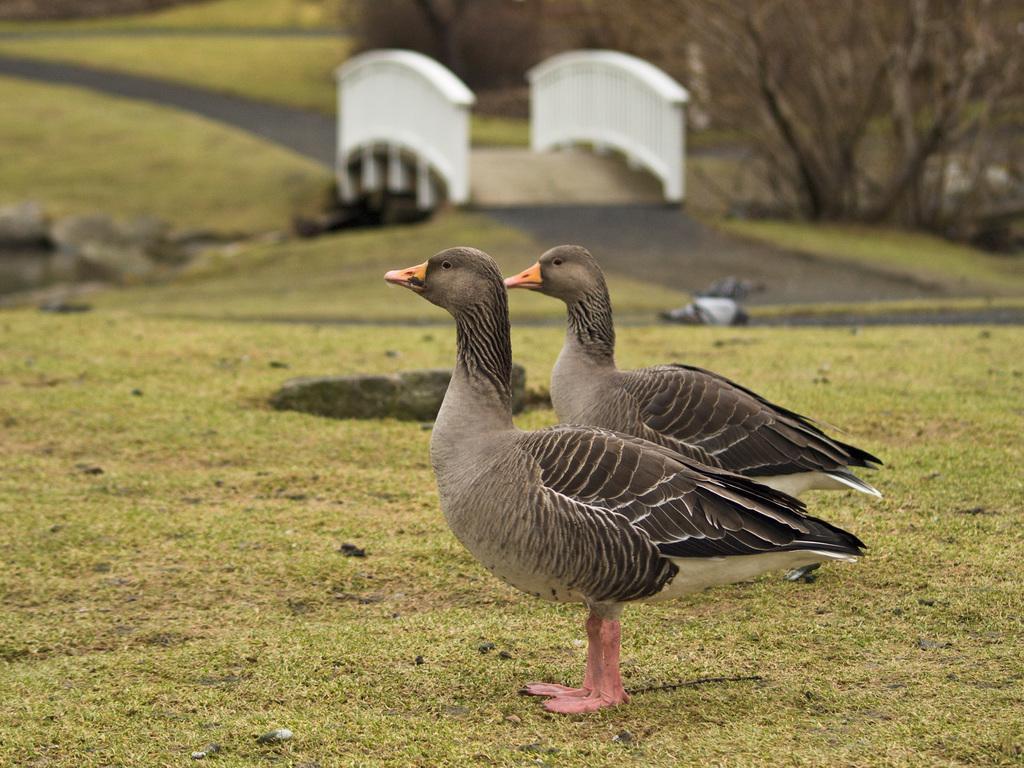How would you summarize this image in a sentence or two? In this image I can see two birds in black and gray color, background I can see grass in green color and I can see few dried trees. 